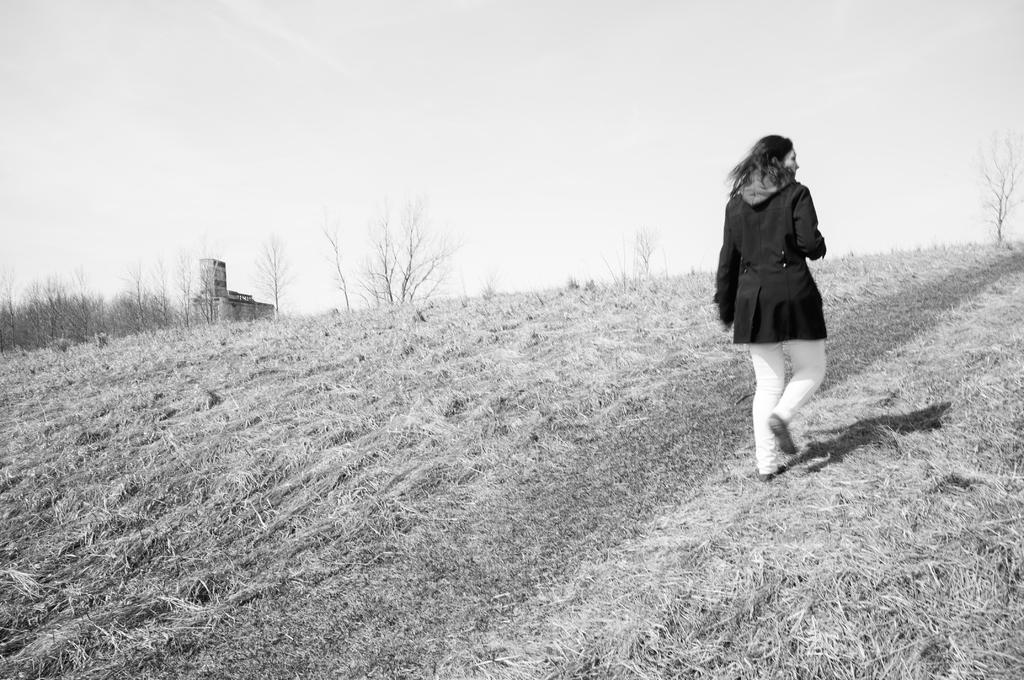What is happening on the right side of the image? There is a lady walking on the right side of the image. What type of terrain is visible at the bottom of the image? There is grass at the bottom of the image. What can be seen in the background of the image? There are trees and the sky visible in the background of the image. Can you see any potatoes growing in the grass in the image? There are no potatoes visible in the image; it only shows grass at the bottom. 